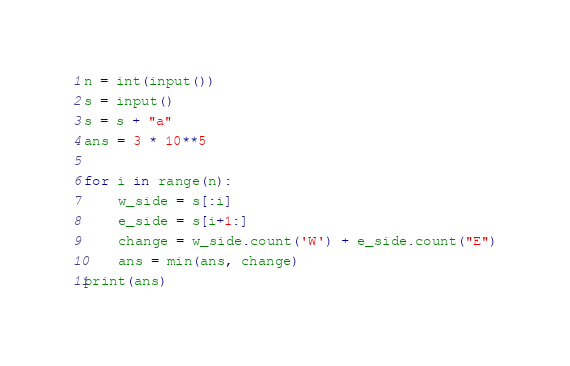<code> <loc_0><loc_0><loc_500><loc_500><_Python_>n = int(input())
s = input()
s = s + "a"
ans = 3 * 10**5

for i in range(n):
    w_side = s[:i]
    e_side = s[i+1:]
    change = w_side.count('W') + e_side.count("E")
    ans = min(ans, change)
print(ans)
</code> 